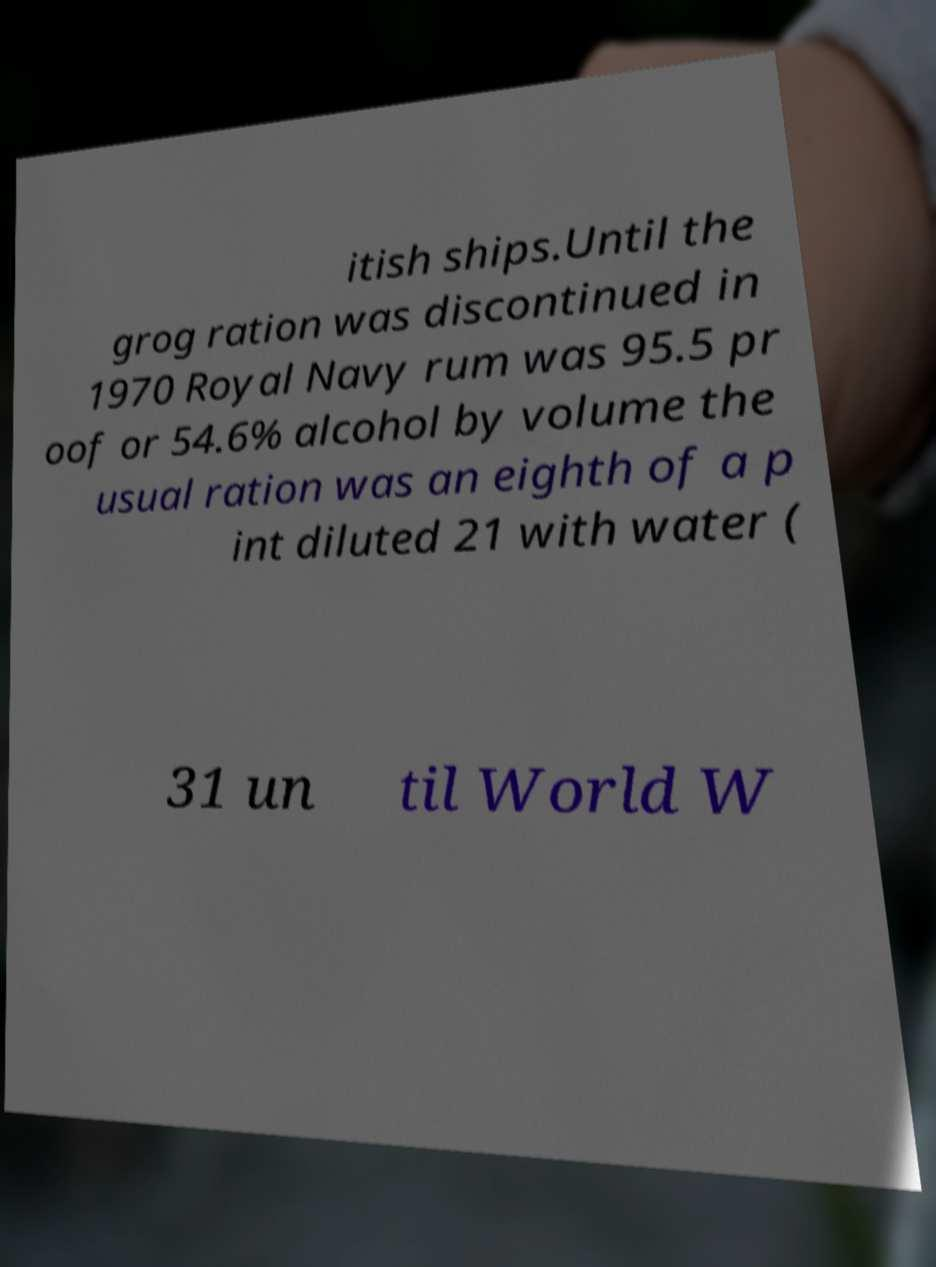What messages or text are displayed in this image? I need them in a readable, typed format. itish ships.Until the grog ration was discontinued in 1970 Royal Navy rum was 95.5 pr oof or 54.6% alcohol by volume the usual ration was an eighth of a p int diluted 21 with water ( 31 un til World W 